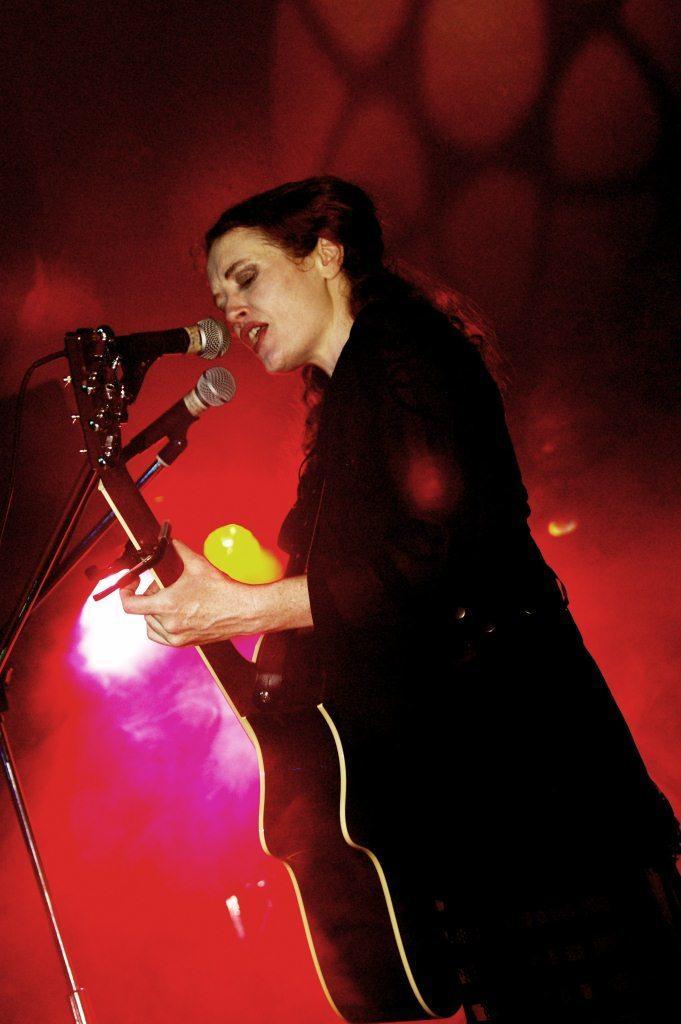Please provide a concise description of this image. In this image there is a girl who is standing and holding the guitar in her hand and singing with the mic which is in front of her. 